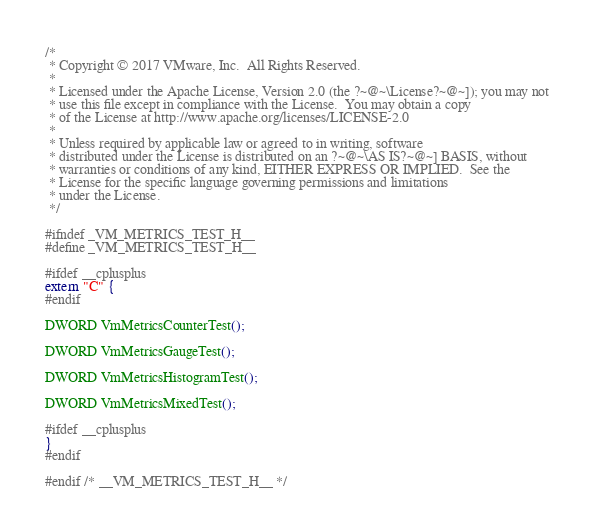<code> <loc_0><loc_0><loc_500><loc_500><_C_>/*
 * Copyright © 2017 VMware, Inc.  All Rights Reserved.
 *
 * Licensed under the Apache License, Version 2.0 (the ?~@~\License?~@~]); you may not
 * use this file except in compliance with the License.  You may obtain a copy
 * of the License at http://www.apache.org/licenses/LICENSE-2.0
 *
 * Unless required by applicable law or agreed to in writing, software
 * distributed under the License is distributed on an ?~@~\AS IS?~@~] BASIS, without
 * warranties or conditions of any kind, EITHER EXPRESS OR IMPLIED.  See the
 * License for the specific language governing permissions and limitations
 * under the License.
 */

#ifndef _VM_METRICS_TEST_H__
#define _VM_METRICS_TEST_H__

#ifdef __cplusplus
extern "C" {
#endif

DWORD VmMetricsCounterTest();

DWORD VmMetricsGaugeTest();

DWORD VmMetricsHistogramTest();

DWORD VmMetricsMixedTest();

#ifdef __cplusplus
}
#endif

#endif /* __VM_METRICS_TEST_H__ */
</code> 